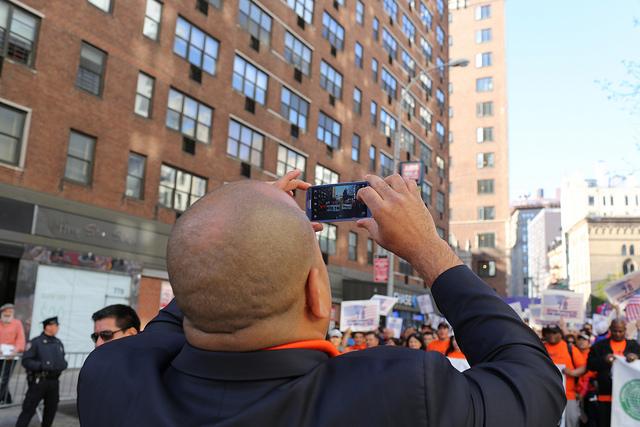Is the man taking a picture?
Short answer required. Yes. Where is the cop in relation to the bearded man?
Write a very short answer. Front. Is this a demonstration?
Write a very short answer. Yes. How many people are wearing orange shirts?
Quick response, please. 10. Are these two people familiar with each other?
Give a very brief answer. No. 